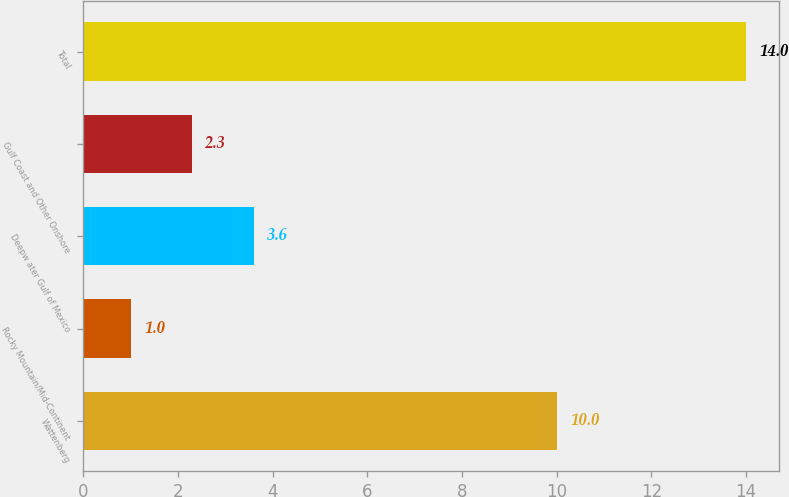<chart> <loc_0><loc_0><loc_500><loc_500><bar_chart><fcel>Wattenberg<fcel>Rocky Mountain/Mid-Continent<fcel>Deepw ater Gulf of Mexico<fcel>Gulf Coast and Other Onshore<fcel>Total<nl><fcel>10<fcel>1<fcel>3.6<fcel>2.3<fcel>14<nl></chart> 